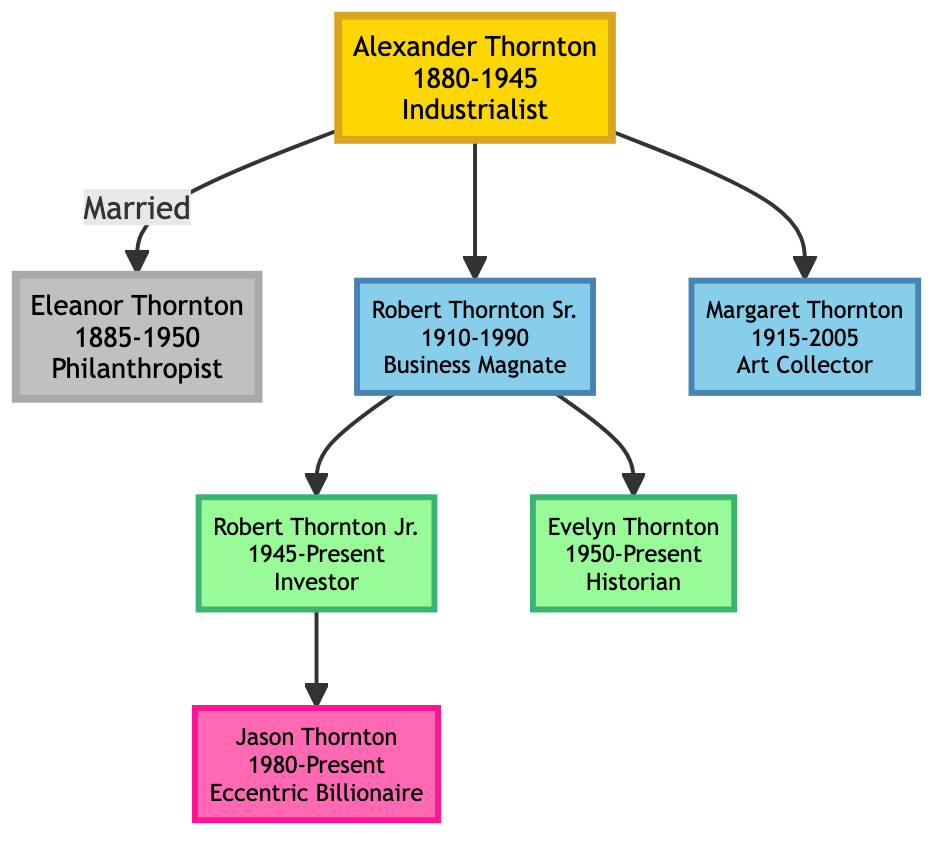What year was Alexander Thornton born? The diagram shows that Alexander Thornton has the birth year displayed as 1880.
Answer: 1880 Who was married to Eleanor Thornton? The diagram indicates that Alexander Thornton is connected to Eleanor Thornton through the marriage link.
Answer: Alexander Thornton What was the profession of Robert Thornton Sr.? The diagram specifies Robert Thornton Sr. as a Business Magnate.
Answer: Business Magnate How many children did Robert Thornton Sr. have? The diagram reveals that Robert Thornton Sr. has two children: Robert Thornton Jr. and Evelyn Thornton.
Answer: 2 What significant contribution did Margaret Thornton make? The diagram states that Margaret Thornton gained recognition for her art collection, including rare early comic book editions.
Answer: Art collection Who is the current generation member? The diagram points to Jason Thornton as the current generation member, highlighted in the last section.
Answer: Jason Thornton What is the financial contribution of Evelyn Thornton? The diagram tells us that Evelyn Thornton curated the family’s comic book collection, significantly increasing its value and historical importance.
Answer: Curated the comic book collection How is Jason Thornton related to Robert Thornton Sr.? The diagram illustrates that Jason Thornton is the grandchild of Robert Thornton Sr., as Robert Thornton Jr. is the son of Robert Thornton Sr., and Jason is the son of Robert Thornton Jr.
Answer: Grandchild Which profession is associated with Eleanor Thornton? The diagram lists Eleanor Thornton's profession as a Philanthropist.
Answer: Philanthropist What year did Margaret Thornton die? According to the diagram, Margaret Thornton's death year is indicated as 2005.
Answer: 2005 